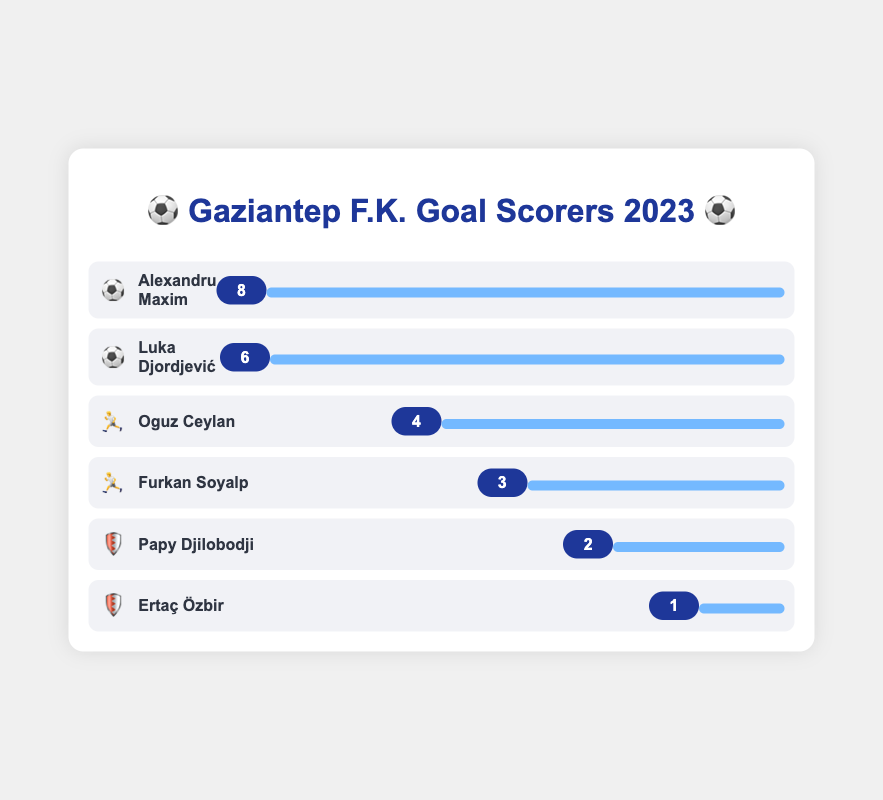Which player scored the most goals? Look at the player with the highest bar in the chart and their corresponding goal number. The highest bar is for Alexandru Maxim with 8 goals.
Answer: Alexandru Maxim How many goals did the top two scorers achieve together? Identify the goals of the top two scorers, Alexandru Maxim (8 goals) and Luka Djordjević (6 goals). Sum them up: 8 + 6 = 14.
Answer: 14 Who are the players in the midfielder position, and how many goals did they score? Find the players represented by the "🏃" emoji. They are Oguz Ceylan (4 goals) and Furkan Soyalp (3 goals).
Answer: Oguz Ceylan (4), Furkan Soyalp (3) Which defender scored more goals, Papy Djilobodji or Ertaç Özbir? Compare the goals of the players represented by the "🛡️" emoji. Papy Djilobodji scored 2 goals, while Ertaç Özbir scored 1 goal.
Answer: Papy Djilobodji What is the total number of goals scored by all the players? Sum the goals of all players: 8 + 6 + 4 + 3 + 2 + 1 = 24.
Answer: 24 How many more goals did Alexandru Maxim score compared to Oguz Ceylan? Subtract Oguz Ceylan's goals (4) from Alexandru Maxim's goals (8): 8 - 4 = 4.
Answer: 4 List the players who scored 2 or fewer goals. Identify the players whose goals are 2 or fewer: Papy Djilobodji (2) and Ertaç Özbir (1).
Answer: Papy Djilobodji, Ertaç Özbir Who is the third highest goal scorer and how many goals did they score? Identify the player with the third bar in height, which is Oguz Ceylan with 4 goals.
Answer: Oguz Ceylan, 4 How many players are forwards (⚽️)? Count the players represented by the "⚽️" emoji. There are 2 players.
Answer: 2 